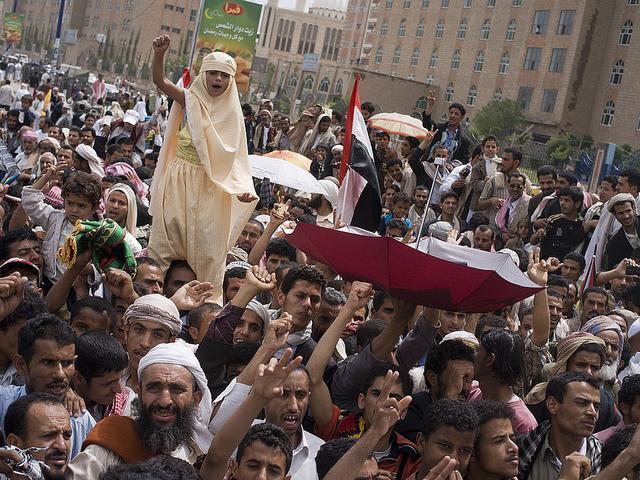How many people are in the picture?
Give a very brief answer. 12. 